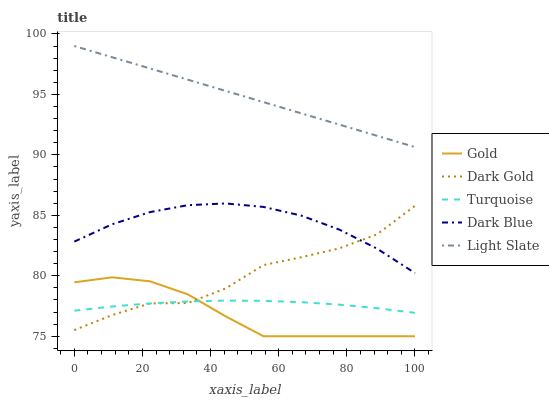Does Gold have the minimum area under the curve?
Answer yes or no. Yes. Does Light Slate have the maximum area under the curve?
Answer yes or no. Yes. Does Dark Blue have the minimum area under the curve?
Answer yes or no. No. Does Dark Blue have the maximum area under the curve?
Answer yes or no. No. Is Light Slate the smoothest?
Answer yes or no. Yes. Is Dark Gold the roughest?
Answer yes or no. Yes. Is Dark Blue the smoothest?
Answer yes or no. No. Is Dark Blue the roughest?
Answer yes or no. No. Does Gold have the lowest value?
Answer yes or no. Yes. Does Dark Blue have the lowest value?
Answer yes or no. No. Does Light Slate have the highest value?
Answer yes or no. Yes. Does Dark Blue have the highest value?
Answer yes or no. No. Is Turquoise less than Dark Blue?
Answer yes or no. Yes. Is Dark Blue greater than Turquoise?
Answer yes or no. Yes. Does Gold intersect Dark Gold?
Answer yes or no. Yes. Is Gold less than Dark Gold?
Answer yes or no. No. Is Gold greater than Dark Gold?
Answer yes or no. No. Does Turquoise intersect Dark Blue?
Answer yes or no. No. 